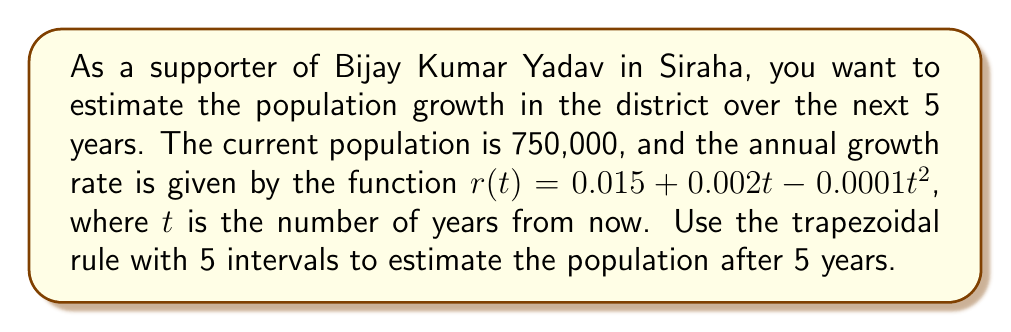Could you help me with this problem? 1) The population growth over time can be modeled by the differential equation:
   $$\frac{dP}{dt} = r(t)P$$

2) To find the population after 5 years, we need to solve:
   $$P(5) = P(0)e^{\int_0^5 r(t)dt}$$

3) We need to estimate $\int_0^5 r(t)dt$ using the trapezoidal rule with 5 intervals.

4) The trapezoidal rule formula for 5 intervals is:
   $$\int_a^b f(x)dx \approx \frac{h}{2}[f(x_0) + 2f(x_1) + 2f(x_2) + 2f(x_3) + 2f(x_4) + f(x_5)]$$
   where $h = \frac{b-a}{5} = \frac{5-0}{5} = 1$

5) Calculate $r(t)$ for $t = 0, 1, 2, 3, 4, 5$:
   $r(0) = 0.015$
   $r(1) = 0.015 + 0.002(1) - 0.0001(1)^2 = 0.0169$
   $r(2) = 0.015 + 0.002(2) - 0.0001(2)^2 = 0.0184$
   $r(3) = 0.015 + 0.002(3) - 0.0001(3)^2 = 0.0195$
   $r(4) = 0.015 + 0.002(4) - 0.0001(4)^2 = 0.0202$
   $r(5) = 0.015 + 0.002(5) - 0.0001(5)^2 = 0.0205$

6) Apply the trapezoidal rule:
   $$\int_0^5 r(t)dt \approx \frac{1}{2}[0.015 + 2(0.0169) + 2(0.0184) + 2(0.0195) + 2(0.0202) + 0.0205] = 0.09275$$

7) Now we can estimate the population after 5 years:
   $$P(5) \approx 750,000 * e^{0.09275} \approx 810,721$$
Answer: 810,721 